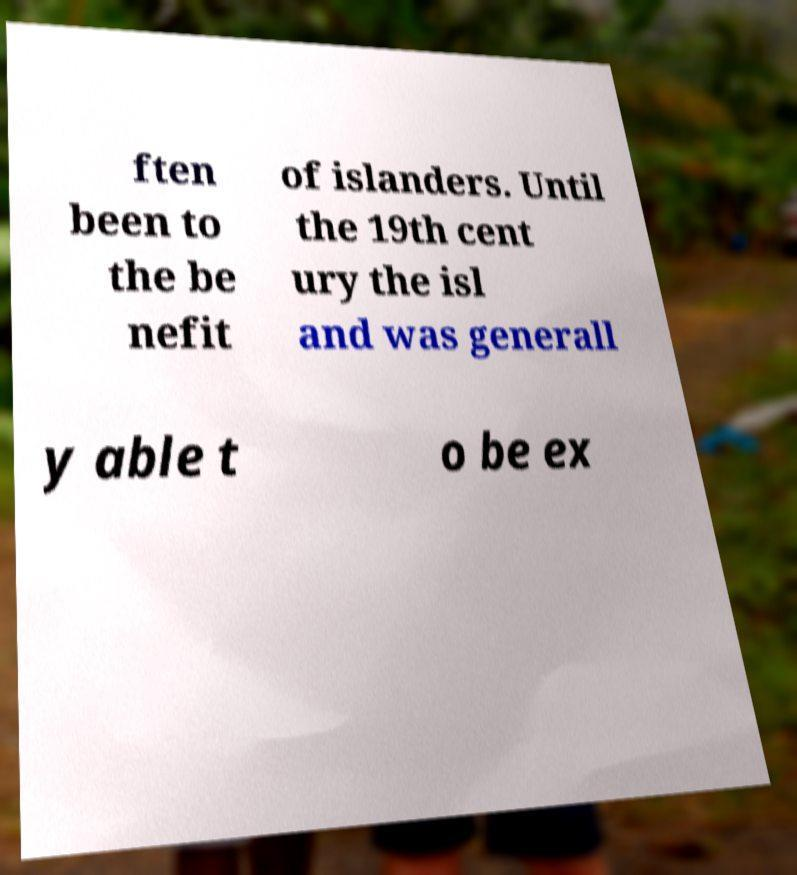Please read and relay the text visible in this image. What does it say? ften been to the be nefit of islanders. Until the 19th cent ury the isl and was generall y able t o be ex 